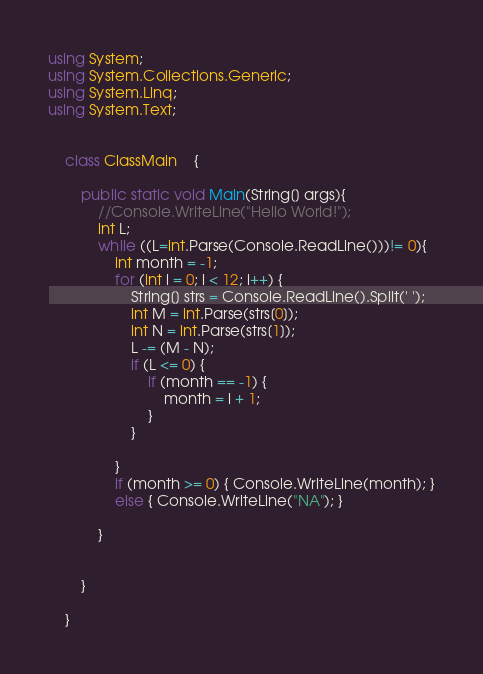Convert code to text. <code><loc_0><loc_0><loc_500><loc_500><_C#_>using System;
using System.Collections.Generic;
using System.Linq;
using System.Text;


    class ClassMain    {

        public static void Main(String[] args){
            //Console.WriteLine("Hello World!");
            int L;
            while ((L=int.Parse(Console.ReadLine()))!= 0){
                int month = -1;
                for (int i = 0; i < 12; i++) {
                    String[] strs = Console.ReadLine().Split(' ');
                    int M = int.Parse(strs[0]);
                    int N = int.Parse(strs[1]);
                    L -= (M - N);
                    if (L <= 0) {
                        if (month == -1) {
                            month = i + 1;
                        }
                    }
                
                }
                if (month >= 0) { Console.WriteLine(month); }
                else { Console.WriteLine("NA"); }

            }


        }

    }</code> 